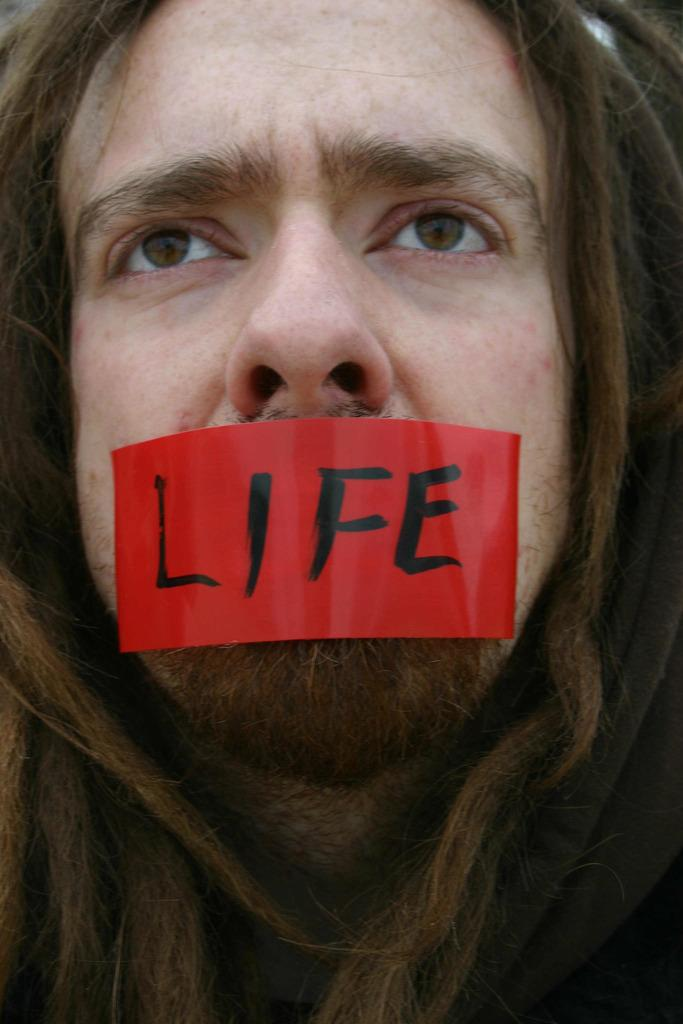What is the main subject of the image? There is a person in the image. Can you describe the person's appearance in the image? The person has a red color plaster on their mouth. What type of brush can be seen in the person's hand in the image? There is no brush visible in the person's hand in the image. What kind of marble structure is present in the background of the image? There is no marble structure present in the image; it only features a person with a red color plaster on their mouth. 